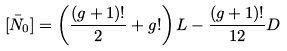<formula> <loc_0><loc_0><loc_500><loc_500>[ \bar { N } _ { 0 } ] = \left ( \frac { ( g + 1 ) ! } { 2 } + g ! \right ) L - \frac { ( g + 1 ) ! } { 1 2 } D</formula> 